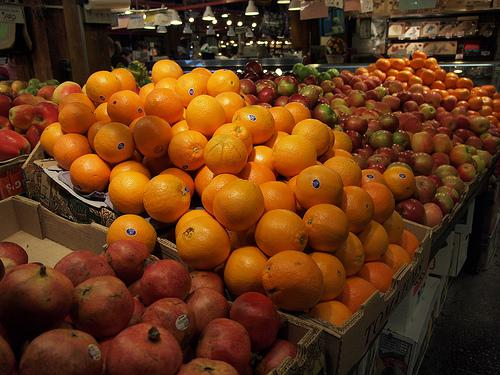Question: what is orange?
Choices:
A. Fruit.
B. Vegetables.
C. Meat.
D. Bread.
Answer with the letter. Answer: A Question: what are fruit in?
Choices:
A. Cardboard.
B. Bowl.
C. Wooden crate.
D. Cup.
Answer with the letter. Answer: A Question: how many fruit types are in the photo?
Choices:
A. About two.
B. About six.
C. About Three.
D. About four.
Answer with the letter. Answer: C Question: where was picture taken?
Choices:
A. Department store.
B. Grocery store.
C. Flower shop.
D. Clothing store.
Answer with the letter. Answer: B Question: why is sticker on the fruit?
Choices:
A. Brand.
B. Price.
C. Promotion.
D. Type of fruit.
Answer with the letter. Answer: A Question: what color is sticker on the oranges?
Choices:
A. Yellow.
B. Blue.
C. Green.
D. Red.
Answer with the letter. Answer: B 